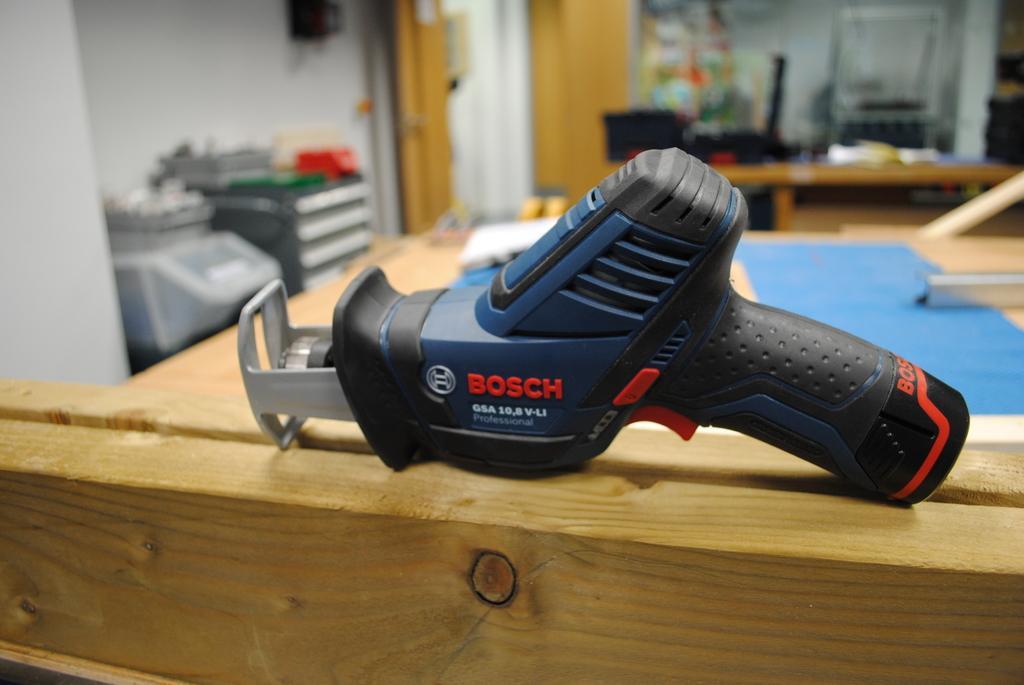How would you summarize this image in a sentence or two? In this picture there is a blue color drill machine placed on the wooden rafters. Behind there is a table and tool boxes. In the background there is a white wall and wooden door. 